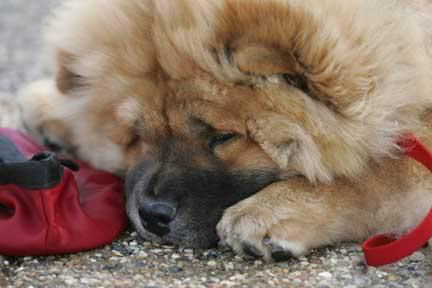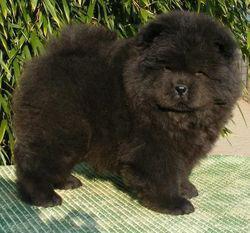The first image is the image on the left, the second image is the image on the right. Evaluate the accuracy of this statement regarding the images: "There is one off white Chow Chow dog in both images.". Is it true? Answer yes or no. No. The first image is the image on the left, the second image is the image on the right. Evaluate the accuracy of this statement regarding the images: "One chow is an adult dog with a flat forward-turned face and thick red orange mane, and no chows have blackish body fur.". Is it true? Answer yes or no. No. 